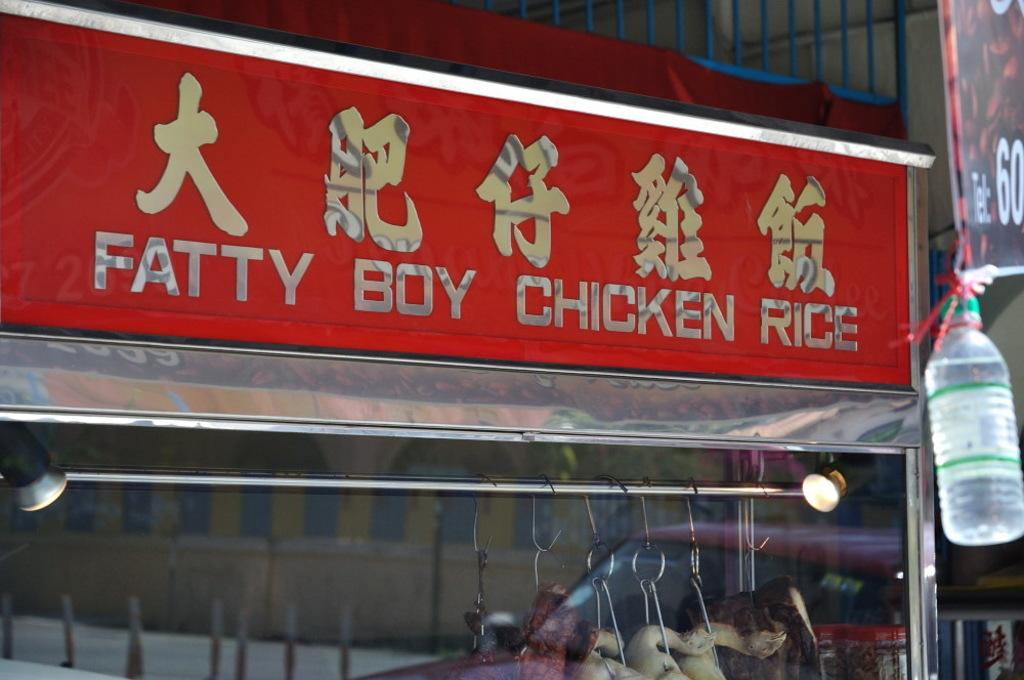<image>
Create a compact narrative representing the image presented. A restaurant sign that says Fatty Boy Chicken Rice. 